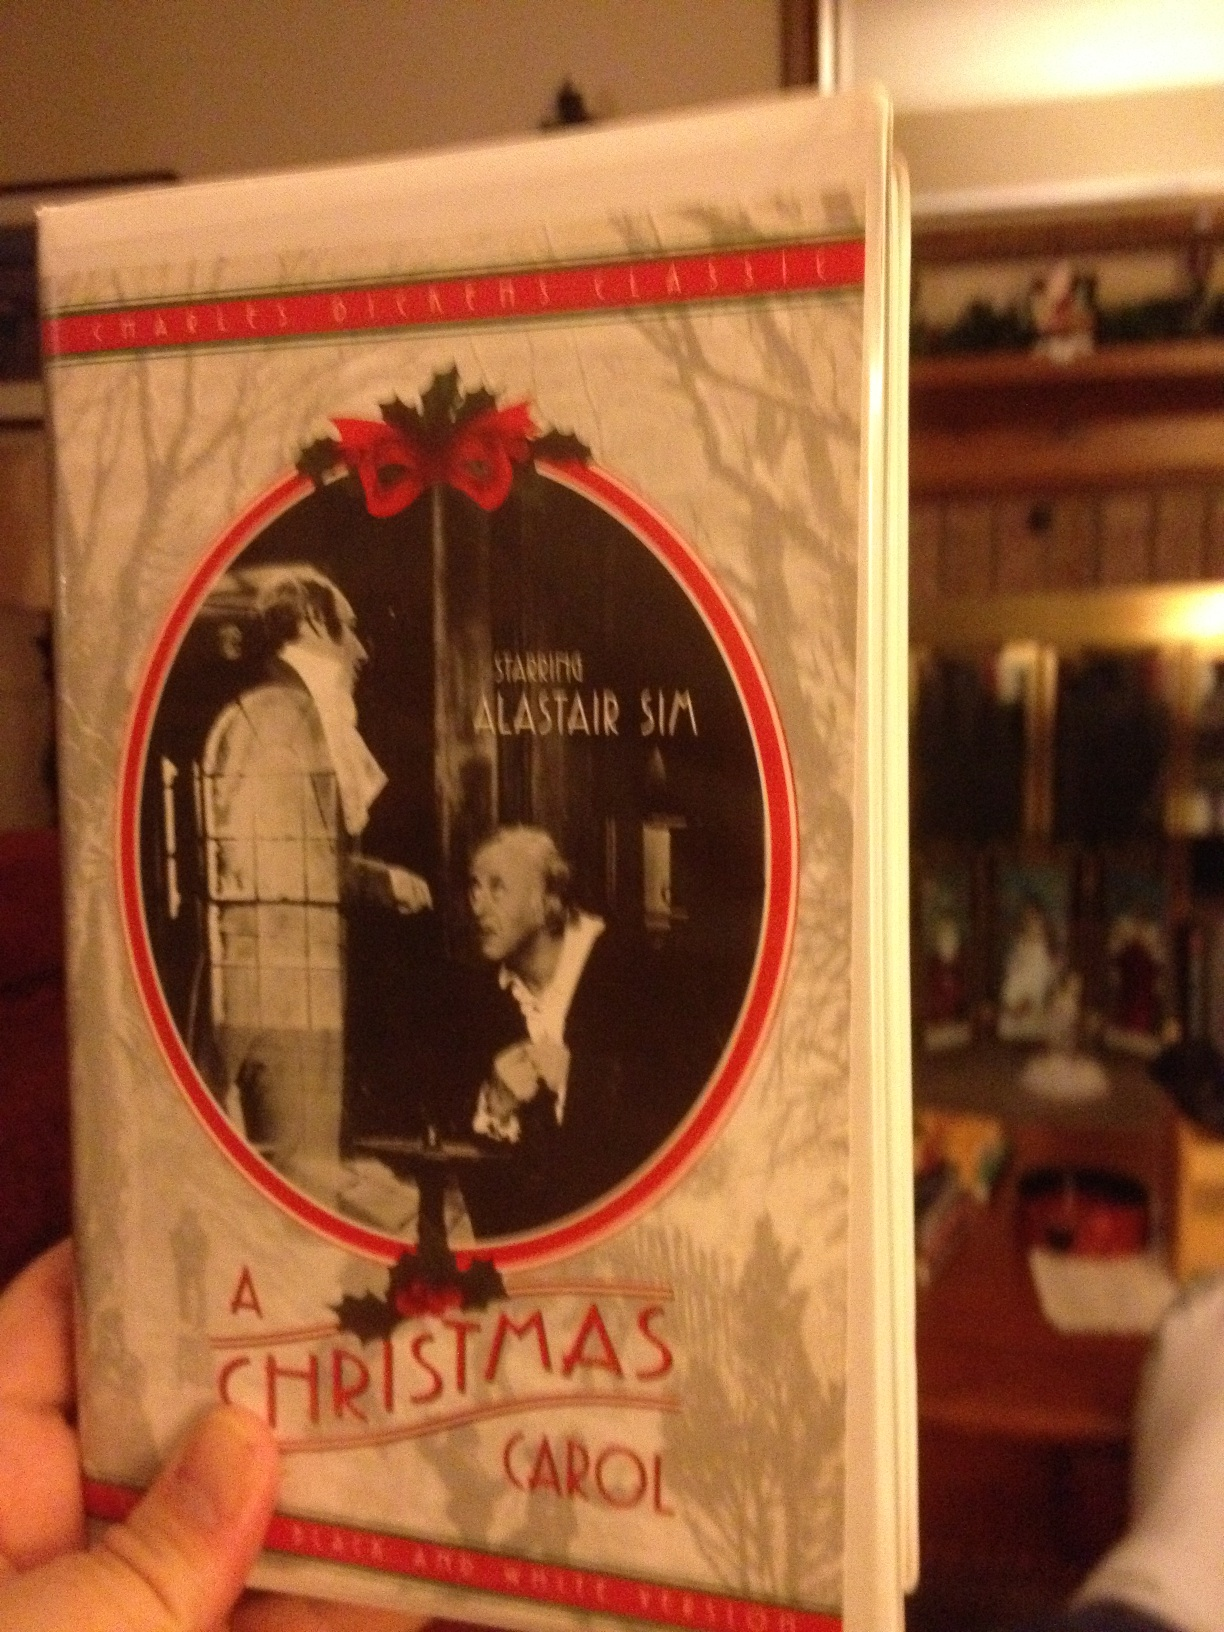How might the themes of this film be relevant to modern audiences? The themes of 'A Christmas Carol' are timeless and remain highly relevant to modern audiences. The story addresses themes such as the importance of compassion, generosity, and personal transformation. In a world where materialism and individualism can often overshadow communal and familial bonds, Scrooge's journey serves as a reminder of the value of empathy and the positive impact of kindness. The exploration of redemption and the ability to change one's ways resonates with contemporary conversations about personal growth and social responsibility. Further, the emphasis on cherishing human connections over wealth highlights enduring truths about what truly makes life meaningful, which continues to be a powerful message for people of all ages. 